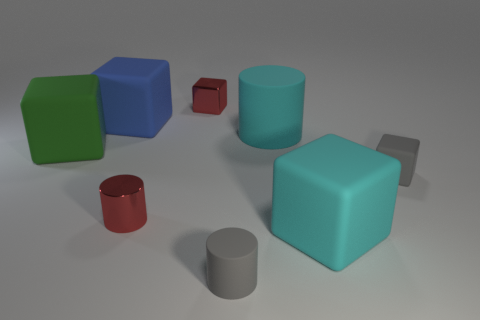Subtract all red metallic cylinders. How many cylinders are left? 2 Subtract all green blocks. How many blocks are left? 4 Add 1 big green blocks. How many objects exist? 9 Subtract all cubes. How many objects are left? 3 Subtract 2 cylinders. How many cylinders are left? 1 Subtract all brown cubes. Subtract all brown cylinders. How many cubes are left? 5 Subtract all cyan balls. How many yellow cylinders are left? 0 Subtract all tiny matte cylinders. Subtract all tiny yellow matte balls. How many objects are left? 7 Add 3 matte cubes. How many matte cubes are left? 7 Add 2 big blue matte objects. How many big blue matte objects exist? 3 